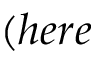Convert formula to latex. <formula><loc_0><loc_0><loc_500><loc_500>( h e r e</formula> 